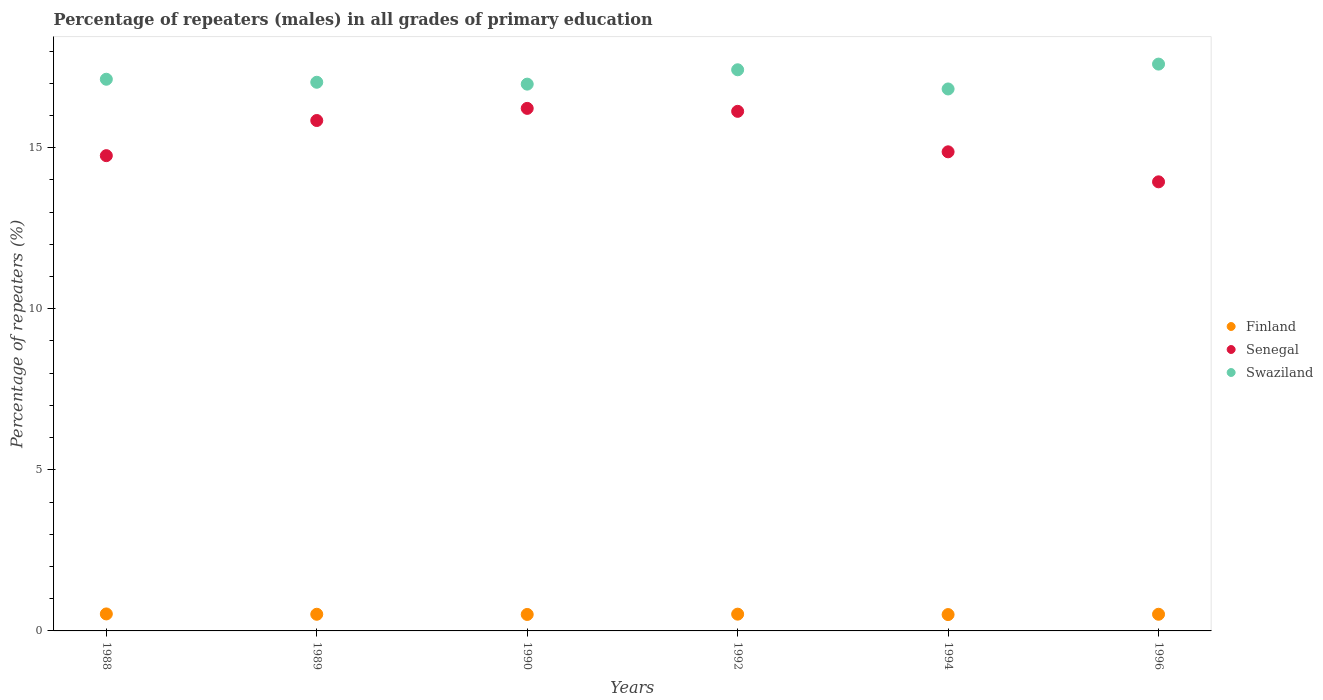How many different coloured dotlines are there?
Ensure brevity in your answer.  3. What is the percentage of repeaters (males) in Senegal in 1996?
Your answer should be compact. 13.94. Across all years, what is the maximum percentage of repeaters (males) in Swaziland?
Make the answer very short. 17.6. Across all years, what is the minimum percentage of repeaters (males) in Senegal?
Ensure brevity in your answer.  13.94. In which year was the percentage of repeaters (males) in Senegal maximum?
Your answer should be compact. 1990. What is the total percentage of repeaters (males) in Finland in the graph?
Offer a very short reply. 3.1. What is the difference between the percentage of repeaters (males) in Swaziland in 1992 and that in 1996?
Ensure brevity in your answer.  -0.18. What is the difference between the percentage of repeaters (males) in Senegal in 1988 and the percentage of repeaters (males) in Swaziland in 1990?
Make the answer very short. -2.22. What is the average percentage of repeaters (males) in Swaziland per year?
Give a very brief answer. 17.16. In the year 1992, what is the difference between the percentage of repeaters (males) in Finland and percentage of repeaters (males) in Senegal?
Make the answer very short. -15.61. In how many years, is the percentage of repeaters (males) in Senegal greater than 16 %?
Your answer should be very brief. 2. What is the ratio of the percentage of repeaters (males) in Senegal in 1989 to that in 1990?
Provide a succinct answer. 0.98. Is the percentage of repeaters (males) in Finland in 1989 less than that in 1996?
Give a very brief answer. Yes. Is the difference between the percentage of repeaters (males) in Finland in 1989 and 1996 greater than the difference between the percentage of repeaters (males) in Senegal in 1989 and 1996?
Your response must be concise. No. What is the difference between the highest and the second highest percentage of repeaters (males) in Swaziland?
Give a very brief answer. 0.18. What is the difference between the highest and the lowest percentage of repeaters (males) in Finland?
Provide a succinct answer. 0.02. Is the sum of the percentage of repeaters (males) in Finland in 1989 and 1992 greater than the maximum percentage of repeaters (males) in Swaziland across all years?
Offer a terse response. No. Is the percentage of repeaters (males) in Finland strictly less than the percentage of repeaters (males) in Swaziland over the years?
Keep it short and to the point. Yes. How many years are there in the graph?
Your response must be concise. 6. Are the values on the major ticks of Y-axis written in scientific E-notation?
Give a very brief answer. No. Does the graph contain any zero values?
Give a very brief answer. No. Where does the legend appear in the graph?
Keep it short and to the point. Center right. What is the title of the graph?
Your answer should be compact. Percentage of repeaters (males) in all grades of primary education. Does "Palau" appear as one of the legend labels in the graph?
Make the answer very short. No. What is the label or title of the X-axis?
Offer a very short reply. Years. What is the label or title of the Y-axis?
Offer a very short reply. Percentage of repeaters (%). What is the Percentage of repeaters (%) in Finland in 1988?
Offer a very short reply. 0.53. What is the Percentage of repeaters (%) in Senegal in 1988?
Provide a short and direct response. 14.75. What is the Percentage of repeaters (%) of Swaziland in 1988?
Offer a terse response. 17.13. What is the Percentage of repeaters (%) of Finland in 1989?
Your answer should be compact. 0.52. What is the Percentage of repeaters (%) in Senegal in 1989?
Ensure brevity in your answer.  15.84. What is the Percentage of repeaters (%) of Swaziland in 1989?
Offer a terse response. 17.03. What is the Percentage of repeaters (%) in Finland in 1990?
Offer a terse response. 0.51. What is the Percentage of repeaters (%) in Senegal in 1990?
Provide a short and direct response. 16.22. What is the Percentage of repeaters (%) in Swaziland in 1990?
Keep it short and to the point. 16.97. What is the Percentage of repeaters (%) in Finland in 1992?
Provide a short and direct response. 0.52. What is the Percentage of repeaters (%) in Senegal in 1992?
Offer a terse response. 16.13. What is the Percentage of repeaters (%) of Swaziland in 1992?
Keep it short and to the point. 17.42. What is the Percentage of repeaters (%) of Finland in 1994?
Your answer should be compact. 0.51. What is the Percentage of repeaters (%) of Senegal in 1994?
Provide a succinct answer. 14.87. What is the Percentage of repeaters (%) of Swaziland in 1994?
Your response must be concise. 16.82. What is the Percentage of repeaters (%) of Finland in 1996?
Your answer should be very brief. 0.52. What is the Percentage of repeaters (%) of Senegal in 1996?
Offer a very short reply. 13.94. What is the Percentage of repeaters (%) in Swaziland in 1996?
Offer a very short reply. 17.6. Across all years, what is the maximum Percentage of repeaters (%) in Finland?
Provide a short and direct response. 0.53. Across all years, what is the maximum Percentage of repeaters (%) of Senegal?
Your answer should be compact. 16.22. Across all years, what is the maximum Percentage of repeaters (%) in Swaziland?
Ensure brevity in your answer.  17.6. Across all years, what is the minimum Percentage of repeaters (%) in Finland?
Make the answer very short. 0.51. Across all years, what is the minimum Percentage of repeaters (%) in Senegal?
Ensure brevity in your answer.  13.94. Across all years, what is the minimum Percentage of repeaters (%) of Swaziland?
Offer a terse response. 16.82. What is the total Percentage of repeaters (%) of Finland in the graph?
Keep it short and to the point. 3.1. What is the total Percentage of repeaters (%) in Senegal in the graph?
Make the answer very short. 91.76. What is the total Percentage of repeaters (%) of Swaziland in the graph?
Provide a short and direct response. 102.97. What is the difference between the Percentage of repeaters (%) of Finland in 1988 and that in 1989?
Provide a short and direct response. 0.01. What is the difference between the Percentage of repeaters (%) in Senegal in 1988 and that in 1989?
Your answer should be compact. -1.09. What is the difference between the Percentage of repeaters (%) of Swaziland in 1988 and that in 1989?
Your answer should be very brief. 0.09. What is the difference between the Percentage of repeaters (%) of Finland in 1988 and that in 1990?
Make the answer very short. 0.02. What is the difference between the Percentage of repeaters (%) in Senegal in 1988 and that in 1990?
Give a very brief answer. -1.47. What is the difference between the Percentage of repeaters (%) in Swaziland in 1988 and that in 1990?
Your answer should be compact. 0.15. What is the difference between the Percentage of repeaters (%) of Finland in 1988 and that in 1992?
Make the answer very short. 0.01. What is the difference between the Percentage of repeaters (%) of Senegal in 1988 and that in 1992?
Make the answer very short. -1.38. What is the difference between the Percentage of repeaters (%) of Swaziland in 1988 and that in 1992?
Give a very brief answer. -0.29. What is the difference between the Percentage of repeaters (%) in Finland in 1988 and that in 1994?
Ensure brevity in your answer.  0.02. What is the difference between the Percentage of repeaters (%) in Senegal in 1988 and that in 1994?
Your response must be concise. -0.12. What is the difference between the Percentage of repeaters (%) of Swaziland in 1988 and that in 1994?
Provide a short and direct response. 0.3. What is the difference between the Percentage of repeaters (%) of Finland in 1988 and that in 1996?
Your response must be concise. 0.01. What is the difference between the Percentage of repeaters (%) of Senegal in 1988 and that in 1996?
Provide a succinct answer. 0.81. What is the difference between the Percentage of repeaters (%) of Swaziland in 1988 and that in 1996?
Give a very brief answer. -0.47. What is the difference between the Percentage of repeaters (%) of Finland in 1989 and that in 1990?
Keep it short and to the point. 0.01. What is the difference between the Percentage of repeaters (%) of Senegal in 1989 and that in 1990?
Keep it short and to the point. -0.38. What is the difference between the Percentage of repeaters (%) of Swaziland in 1989 and that in 1990?
Provide a succinct answer. 0.06. What is the difference between the Percentage of repeaters (%) in Finland in 1989 and that in 1992?
Your answer should be compact. -0. What is the difference between the Percentage of repeaters (%) of Senegal in 1989 and that in 1992?
Your answer should be very brief. -0.28. What is the difference between the Percentage of repeaters (%) of Swaziland in 1989 and that in 1992?
Provide a short and direct response. -0.39. What is the difference between the Percentage of repeaters (%) in Finland in 1989 and that in 1994?
Provide a succinct answer. 0.01. What is the difference between the Percentage of repeaters (%) of Senegal in 1989 and that in 1994?
Give a very brief answer. 0.97. What is the difference between the Percentage of repeaters (%) of Swaziland in 1989 and that in 1994?
Offer a terse response. 0.21. What is the difference between the Percentage of repeaters (%) of Finland in 1989 and that in 1996?
Ensure brevity in your answer.  -0. What is the difference between the Percentage of repeaters (%) in Senegal in 1989 and that in 1996?
Provide a succinct answer. 1.9. What is the difference between the Percentage of repeaters (%) of Swaziland in 1989 and that in 1996?
Provide a short and direct response. -0.56. What is the difference between the Percentage of repeaters (%) of Finland in 1990 and that in 1992?
Your answer should be compact. -0.01. What is the difference between the Percentage of repeaters (%) of Senegal in 1990 and that in 1992?
Offer a very short reply. 0.09. What is the difference between the Percentage of repeaters (%) of Swaziland in 1990 and that in 1992?
Your answer should be compact. -0.45. What is the difference between the Percentage of repeaters (%) in Finland in 1990 and that in 1994?
Your answer should be very brief. 0. What is the difference between the Percentage of repeaters (%) of Senegal in 1990 and that in 1994?
Offer a terse response. 1.35. What is the difference between the Percentage of repeaters (%) of Swaziland in 1990 and that in 1994?
Your response must be concise. 0.15. What is the difference between the Percentage of repeaters (%) in Finland in 1990 and that in 1996?
Provide a succinct answer. -0.01. What is the difference between the Percentage of repeaters (%) in Senegal in 1990 and that in 1996?
Your response must be concise. 2.28. What is the difference between the Percentage of repeaters (%) in Swaziland in 1990 and that in 1996?
Offer a very short reply. -0.62. What is the difference between the Percentage of repeaters (%) of Finland in 1992 and that in 1994?
Keep it short and to the point. 0.01. What is the difference between the Percentage of repeaters (%) in Senegal in 1992 and that in 1994?
Give a very brief answer. 1.26. What is the difference between the Percentage of repeaters (%) of Swaziland in 1992 and that in 1994?
Your answer should be compact. 0.6. What is the difference between the Percentage of repeaters (%) in Finland in 1992 and that in 1996?
Your answer should be very brief. 0. What is the difference between the Percentage of repeaters (%) of Senegal in 1992 and that in 1996?
Your response must be concise. 2.19. What is the difference between the Percentage of repeaters (%) of Swaziland in 1992 and that in 1996?
Give a very brief answer. -0.18. What is the difference between the Percentage of repeaters (%) of Finland in 1994 and that in 1996?
Your answer should be very brief. -0.01. What is the difference between the Percentage of repeaters (%) of Senegal in 1994 and that in 1996?
Make the answer very short. 0.93. What is the difference between the Percentage of repeaters (%) in Swaziland in 1994 and that in 1996?
Provide a succinct answer. -0.77. What is the difference between the Percentage of repeaters (%) of Finland in 1988 and the Percentage of repeaters (%) of Senegal in 1989?
Provide a short and direct response. -15.32. What is the difference between the Percentage of repeaters (%) in Finland in 1988 and the Percentage of repeaters (%) in Swaziland in 1989?
Your answer should be compact. -16.5. What is the difference between the Percentage of repeaters (%) of Senegal in 1988 and the Percentage of repeaters (%) of Swaziland in 1989?
Give a very brief answer. -2.28. What is the difference between the Percentage of repeaters (%) in Finland in 1988 and the Percentage of repeaters (%) in Senegal in 1990?
Provide a short and direct response. -15.69. What is the difference between the Percentage of repeaters (%) of Finland in 1988 and the Percentage of repeaters (%) of Swaziland in 1990?
Keep it short and to the point. -16.45. What is the difference between the Percentage of repeaters (%) in Senegal in 1988 and the Percentage of repeaters (%) in Swaziland in 1990?
Offer a very short reply. -2.22. What is the difference between the Percentage of repeaters (%) in Finland in 1988 and the Percentage of repeaters (%) in Senegal in 1992?
Keep it short and to the point. -15.6. What is the difference between the Percentage of repeaters (%) in Finland in 1988 and the Percentage of repeaters (%) in Swaziland in 1992?
Your answer should be compact. -16.89. What is the difference between the Percentage of repeaters (%) of Senegal in 1988 and the Percentage of repeaters (%) of Swaziland in 1992?
Your answer should be very brief. -2.67. What is the difference between the Percentage of repeaters (%) of Finland in 1988 and the Percentage of repeaters (%) of Senegal in 1994?
Provide a succinct answer. -14.35. What is the difference between the Percentage of repeaters (%) in Finland in 1988 and the Percentage of repeaters (%) in Swaziland in 1994?
Your response must be concise. -16.3. What is the difference between the Percentage of repeaters (%) in Senegal in 1988 and the Percentage of repeaters (%) in Swaziland in 1994?
Your response must be concise. -2.07. What is the difference between the Percentage of repeaters (%) of Finland in 1988 and the Percentage of repeaters (%) of Senegal in 1996?
Ensure brevity in your answer.  -13.41. What is the difference between the Percentage of repeaters (%) of Finland in 1988 and the Percentage of repeaters (%) of Swaziland in 1996?
Give a very brief answer. -17.07. What is the difference between the Percentage of repeaters (%) of Senegal in 1988 and the Percentage of repeaters (%) of Swaziland in 1996?
Make the answer very short. -2.84. What is the difference between the Percentage of repeaters (%) in Finland in 1989 and the Percentage of repeaters (%) in Senegal in 1990?
Your response must be concise. -15.7. What is the difference between the Percentage of repeaters (%) in Finland in 1989 and the Percentage of repeaters (%) in Swaziland in 1990?
Your response must be concise. -16.46. What is the difference between the Percentage of repeaters (%) of Senegal in 1989 and the Percentage of repeaters (%) of Swaziland in 1990?
Your answer should be compact. -1.13. What is the difference between the Percentage of repeaters (%) of Finland in 1989 and the Percentage of repeaters (%) of Senegal in 1992?
Give a very brief answer. -15.61. What is the difference between the Percentage of repeaters (%) in Finland in 1989 and the Percentage of repeaters (%) in Swaziland in 1992?
Give a very brief answer. -16.9. What is the difference between the Percentage of repeaters (%) in Senegal in 1989 and the Percentage of repeaters (%) in Swaziland in 1992?
Keep it short and to the point. -1.57. What is the difference between the Percentage of repeaters (%) in Finland in 1989 and the Percentage of repeaters (%) in Senegal in 1994?
Provide a short and direct response. -14.36. What is the difference between the Percentage of repeaters (%) in Finland in 1989 and the Percentage of repeaters (%) in Swaziland in 1994?
Provide a succinct answer. -16.31. What is the difference between the Percentage of repeaters (%) of Senegal in 1989 and the Percentage of repeaters (%) of Swaziland in 1994?
Ensure brevity in your answer.  -0.98. What is the difference between the Percentage of repeaters (%) of Finland in 1989 and the Percentage of repeaters (%) of Senegal in 1996?
Provide a succinct answer. -13.42. What is the difference between the Percentage of repeaters (%) in Finland in 1989 and the Percentage of repeaters (%) in Swaziland in 1996?
Give a very brief answer. -17.08. What is the difference between the Percentage of repeaters (%) of Senegal in 1989 and the Percentage of repeaters (%) of Swaziland in 1996?
Your response must be concise. -1.75. What is the difference between the Percentage of repeaters (%) in Finland in 1990 and the Percentage of repeaters (%) in Senegal in 1992?
Your answer should be very brief. -15.62. What is the difference between the Percentage of repeaters (%) of Finland in 1990 and the Percentage of repeaters (%) of Swaziland in 1992?
Provide a short and direct response. -16.91. What is the difference between the Percentage of repeaters (%) of Senegal in 1990 and the Percentage of repeaters (%) of Swaziland in 1992?
Offer a terse response. -1.2. What is the difference between the Percentage of repeaters (%) in Finland in 1990 and the Percentage of repeaters (%) in Senegal in 1994?
Your answer should be compact. -14.36. What is the difference between the Percentage of repeaters (%) of Finland in 1990 and the Percentage of repeaters (%) of Swaziland in 1994?
Your answer should be compact. -16.31. What is the difference between the Percentage of repeaters (%) in Senegal in 1990 and the Percentage of repeaters (%) in Swaziland in 1994?
Ensure brevity in your answer.  -0.6. What is the difference between the Percentage of repeaters (%) in Finland in 1990 and the Percentage of repeaters (%) in Senegal in 1996?
Keep it short and to the point. -13.43. What is the difference between the Percentage of repeaters (%) of Finland in 1990 and the Percentage of repeaters (%) of Swaziland in 1996?
Offer a very short reply. -17.08. What is the difference between the Percentage of repeaters (%) in Senegal in 1990 and the Percentage of repeaters (%) in Swaziland in 1996?
Give a very brief answer. -1.37. What is the difference between the Percentage of repeaters (%) in Finland in 1992 and the Percentage of repeaters (%) in Senegal in 1994?
Keep it short and to the point. -14.35. What is the difference between the Percentage of repeaters (%) of Finland in 1992 and the Percentage of repeaters (%) of Swaziland in 1994?
Offer a terse response. -16.3. What is the difference between the Percentage of repeaters (%) of Senegal in 1992 and the Percentage of repeaters (%) of Swaziland in 1994?
Offer a terse response. -0.69. What is the difference between the Percentage of repeaters (%) in Finland in 1992 and the Percentage of repeaters (%) in Senegal in 1996?
Make the answer very short. -13.42. What is the difference between the Percentage of repeaters (%) of Finland in 1992 and the Percentage of repeaters (%) of Swaziland in 1996?
Keep it short and to the point. -17.07. What is the difference between the Percentage of repeaters (%) in Senegal in 1992 and the Percentage of repeaters (%) in Swaziland in 1996?
Ensure brevity in your answer.  -1.47. What is the difference between the Percentage of repeaters (%) in Finland in 1994 and the Percentage of repeaters (%) in Senegal in 1996?
Your answer should be very brief. -13.43. What is the difference between the Percentage of repeaters (%) of Finland in 1994 and the Percentage of repeaters (%) of Swaziland in 1996?
Provide a succinct answer. -17.09. What is the difference between the Percentage of repeaters (%) in Senegal in 1994 and the Percentage of repeaters (%) in Swaziland in 1996?
Ensure brevity in your answer.  -2.72. What is the average Percentage of repeaters (%) of Finland per year?
Your answer should be compact. 0.52. What is the average Percentage of repeaters (%) in Senegal per year?
Give a very brief answer. 15.29. What is the average Percentage of repeaters (%) in Swaziland per year?
Provide a short and direct response. 17.16. In the year 1988, what is the difference between the Percentage of repeaters (%) of Finland and Percentage of repeaters (%) of Senegal?
Offer a terse response. -14.23. In the year 1988, what is the difference between the Percentage of repeaters (%) of Finland and Percentage of repeaters (%) of Swaziland?
Offer a very short reply. -16.6. In the year 1988, what is the difference between the Percentage of repeaters (%) in Senegal and Percentage of repeaters (%) in Swaziland?
Your response must be concise. -2.37. In the year 1989, what is the difference between the Percentage of repeaters (%) of Finland and Percentage of repeaters (%) of Senegal?
Provide a short and direct response. -15.33. In the year 1989, what is the difference between the Percentage of repeaters (%) in Finland and Percentage of repeaters (%) in Swaziland?
Make the answer very short. -16.51. In the year 1989, what is the difference between the Percentage of repeaters (%) of Senegal and Percentage of repeaters (%) of Swaziland?
Provide a short and direct response. -1.19. In the year 1990, what is the difference between the Percentage of repeaters (%) in Finland and Percentage of repeaters (%) in Senegal?
Your answer should be very brief. -15.71. In the year 1990, what is the difference between the Percentage of repeaters (%) of Finland and Percentage of repeaters (%) of Swaziland?
Keep it short and to the point. -16.46. In the year 1990, what is the difference between the Percentage of repeaters (%) of Senegal and Percentage of repeaters (%) of Swaziland?
Ensure brevity in your answer.  -0.75. In the year 1992, what is the difference between the Percentage of repeaters (%) in Finland and Percentage of repeaters (%) in Senegal?
Make the answer very short. -15.61. In the year 1992, what is the difference between the Percentage of repeaters (%) of Finland and Percentage of repeaters (%) of Swaziland?
Offer a very short reply. -16.9. In the year 1992, what is the difference between the Percentage of repeaters (%) of Senegal and Percentage of repeaters (%) of Swaziland?
Provide a short and direct response. -1.29. In the year 1994, what is the difference between the Percentage of repeaters (%) of Finland and Percentage of repeaters (%) of Senegal?
Your response must be concise. -14.36. In the year 1994, what is the difference between the Percentage of repeaters (%) of Finland and Percentage of repeaters (%) of Swaziland?
Make the answer very short. -16.32. In the year 1994, what is the difference between the Percentage of repeaters (%) in Senegal and Percentage of repeaters (%) in Swaziland?
Provide a short and direct response. -1.95. In the year 1996, what is the difference between the Percentage of repeaters (%) of Finland and Percentage of repeaters (%) of Senegal?
Provide a succinct answer. -13.42. In the year 1996, what is the difference between the Percentage of repeaters (%) of Finland and Percentage of repeaters (%) of Swaziland?
Your answer should be very brief. -17.08. In the year 1996, what is the difference between the Percentage of repeaters (%) of Senegal and Percentage of repeaters (%) of Swaziland?
Your answer should be compact. -3.65. What is the ratio of the Percentage of repeaters (%) in Finland in 1988 to that in 1989?
Keep it short and to the point. 1.02. What is the ratio of the Percentage of repeaters (%) in Senegal in 1988 to that in 1989?
Offer a very short reply. 0.93. What is the ratio of the Percentage of repeaters (%) of Finland in 1988 to that in 1990?
Provide a short and direct response. 1.03. What is the ratio of the Percentage of repeaters (%) in Senegal in 1988 to that in 1990?
Offer a very short reply. 0.91. What is the ratio of the Percentage of repeaters (%) of Finland in 1988 to that in 1992?
Provide a short and direct response. 1.01. What is the ratio of the Percentage of repeaters (%) in Senegal in 1988 to that in 1992?
Provide a short and direct response. 0.91. What is the ratio of the Percentage of repeaters (%) of Swaziland in 1988 to that in 1992?
Provide a succinct answer. 0.98. What is the ratio of the Percentage of repeaters (%) of Finland in 1988 to that in 1994?
Your answer should be very brief. 1.04. What is the ratio of the Percentage of repeaters (%) of Senegal in 1988 to that in 1994?
Provide a succinct answer. 0.99. What is the ratio of the Percentage of repeaters (%) of Swaziland in 1988 to that in 1994?
Your response must be concise. 1.02. What is the ratio of the Percentage of repeaters (%) in Finland in 1988 to that in 1996?
Provide a succinct answer. 1.02. What is the ratio of the Percentage of repeaters (%) of Senegal in 1988 to that in 1996?
Keep it short and to the point. 1.06. What is the ratio of the Percentage of repeaters (%) of Swaziland in 1988 to that in 1996?
Give a very brief answer. 0.97. What is the ratio of the Percentage of repeaters (%) of Finland in 1989 to that in 1990?
Keep it short and to the point. 1.01. What is the ratio of the Percentage of repeaters (%) in Senegal in 1989 to that in 1990?
Your answer should be very brief. 0.98. What is the ratio of the Percentage of repeaters (%) in Finland in 1989 to that in 1992?
Make the answer very short. 0.99. What is the ratio of the Percentage of repeaters (%) of Senegal in 1989 to that in 1992?
Your response must be concise. 0.98. What is the ratio of the Percentage of repeaters (%) in Swaziland in 1989 to that in 1992?
Your answer should be very brief. 0.98. What is the ratio of the Percentage of repeaters (%) in Finland in 1989 to that in 1994?
Give a very brief answer. 1.02. What is the ratio of the Percentage of repeaters (%) of Senegal in 1989 to that in 1994?
Ensure brevity in your answer.  1.07. What is the ratio of the Percentage of repeaters (%) in Swaziland in 1989 to that in 1994?
Offer a terse response. 1.01. What is the ratio of the Percentage of repeaters (%) of Senegal in 1989 to that in 1996?
Give a very brief answer. 1.14. What is the ratio of the Percentage of repeaters (%) of Swaziland in 1989 to that in 1996?
Make the answer very short. 0.97. What is the ratio of the Percentage of repeaters (%) of Finland in 1990 to that in 1992?
Offer a terse response. 0.98. What is the ratio of the Percentage of repeaters (%) of Swaziland in 1990 to that in 1992?
Your answer should be compact. 0.97. What is the ratio of the Percentage of repeaters (%) of Finland in 1990 to that in 1994?
Ensure brevity in your answer.  1.01. What is the ratio of the Percentage of repeaters (%) of Senegal in 1990 to that in 1994?
Give a very brief answer. 1.09. What is the ratio of the Percentage of repeaters (%) of Swaziland in 1990 to that in 1994?
Offer a terse response. 1.01. What is the ratio of the Percentage of repeaters (%) in Finland in 1990 to that in 1996?
Your answer should be very brief. 0.99. What is the ratio of the Percentage of repeaters (%) in Senegal in 1990 to that in 1996?
Offer a very short reply. 1.16. What is the ratio of the Percentage of repeaters (%) of Swaziland in 1990 to that in 1996?
Make the answer very short. 0.96. What is the ratio of the Percentage of repeaters (%) in Finland in 1992 to that in 1994?
Provide a succinct answer. 1.03. What is the ratio of the Percentage of repeaters (%) in Senegal in 1992 to that in 1994?
Give a very brief answer. 1.08. What is the ratio of the Percentage of repeaters (%) in Swaziland in 1992 to that in 1994?
Offer a very short reply. 1.04. What is the ratio of the Percentage of repeaters (%) of Senegal in 1992 to that in 1996?
Give a very brief answer. 1.16. What is the ratio of the Percentage of repeaters (%) of Finland in 1994 to that in 1996?
Provide a succinct answer. 0.98. What is the ratio of the Percentage of repeaters (%) of Senegal in 1994 to that in 1996?
Your answer should be compact. 1.07. What is the ratio of the Percentage of repeaters (%) of Swaziland in 1994 to that in 1996?
Your response must be concise. 0.96. What is the difference between the highest and the second highest Percentage of repeaters (%) in Finland?
Offer a very short reply. 0.01. What is the difference between the highest and the second highest Percentage of repeaters (%) of Senegal?
Give a very brief answer. 0.09. What is the difference between the highest and the second highest Percentage of repeaters (%) in Swaziland?
Give a very brief answer. 0.18. What is the difference between the highest and the lowest Percentage of repeaters (%) in Finland?
Provide a succinct answer. 0.02. What is the difference between the highest and the lowest Percentage of repeaters (%) of Senegal?
Give a very brief answer. 2.28. What is the difference between the highest and the lowest Percentage of repeaters (%) in Swaziland?
Ensure brevity in your answer.  0.77. 